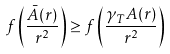Convert formula to latex. <formula><loc_0><loc_0><loc_500><loc_500>f \left ( \frac { \bar { A } ( r ) } { r ^ { 2 } } \right ) \geq f \left ( \frac { \gamma _ { T } A ( r ) } { r ^ { 2 } } \right )</formula> 